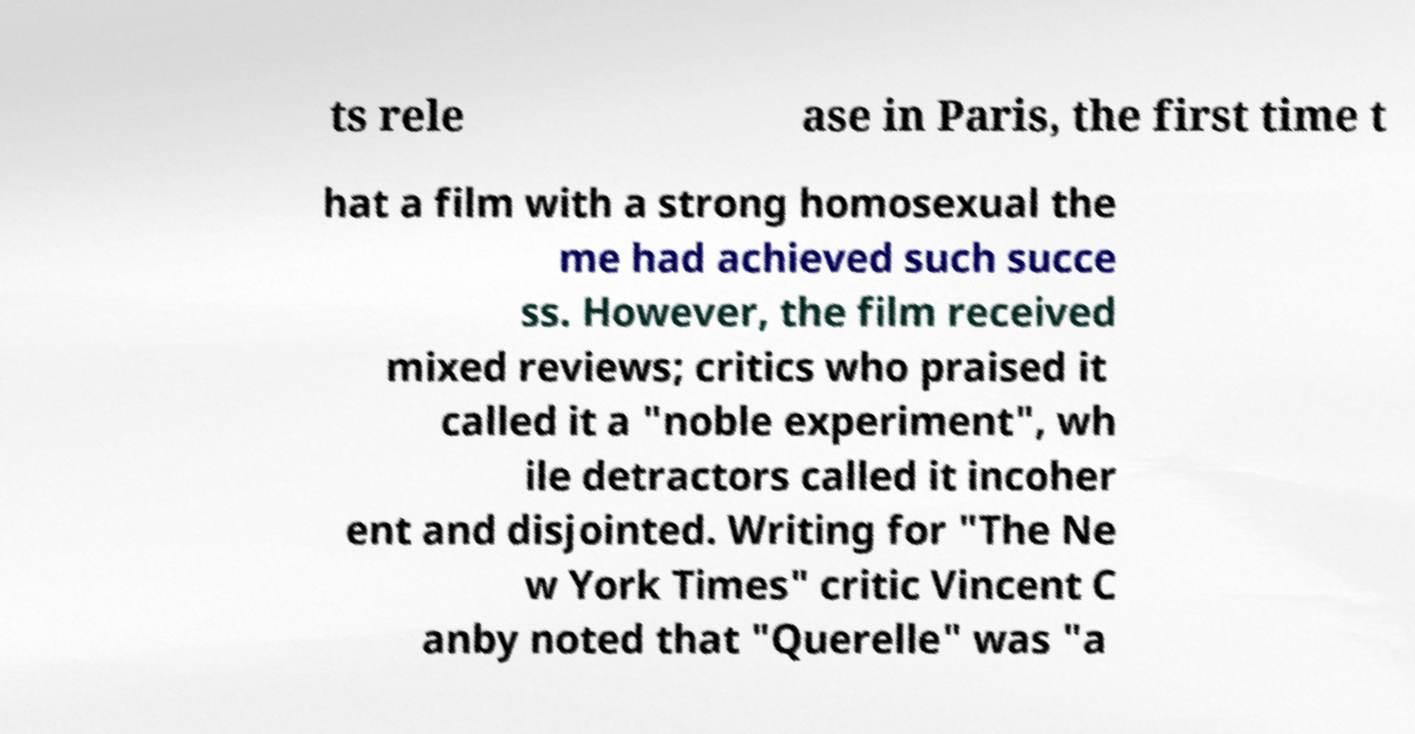Could you assist in decoding the text presented in this image and type it out clearly? ts rele ase in Paris, the first time t hat a film with a strong homosexual the me had achieved such succe ss. However, the film received mixed reviews; critics who praised it called it a "noble experiment", wh ile detractors called it incoher ent and disjointed. Writing for "The Ne w York Times" critic Vincent C anby noted that "Querelle" was "a 